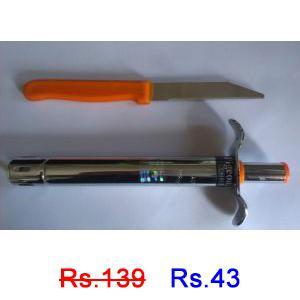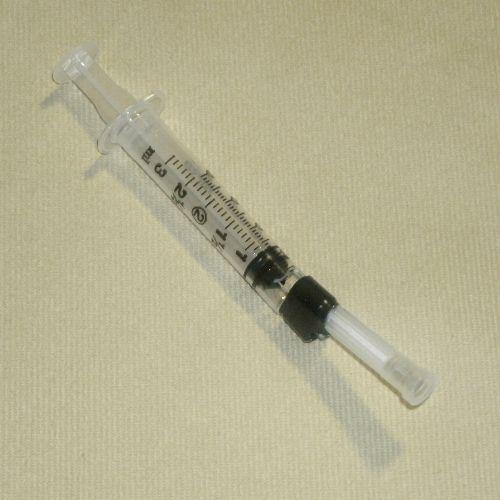The first image is the image on the left, the second image is the image on the right. Evaluate the accuracy of this statement regarding the images: "There is a white razor knife in the image on the right.". Is it true? Answer yes or no. No. 